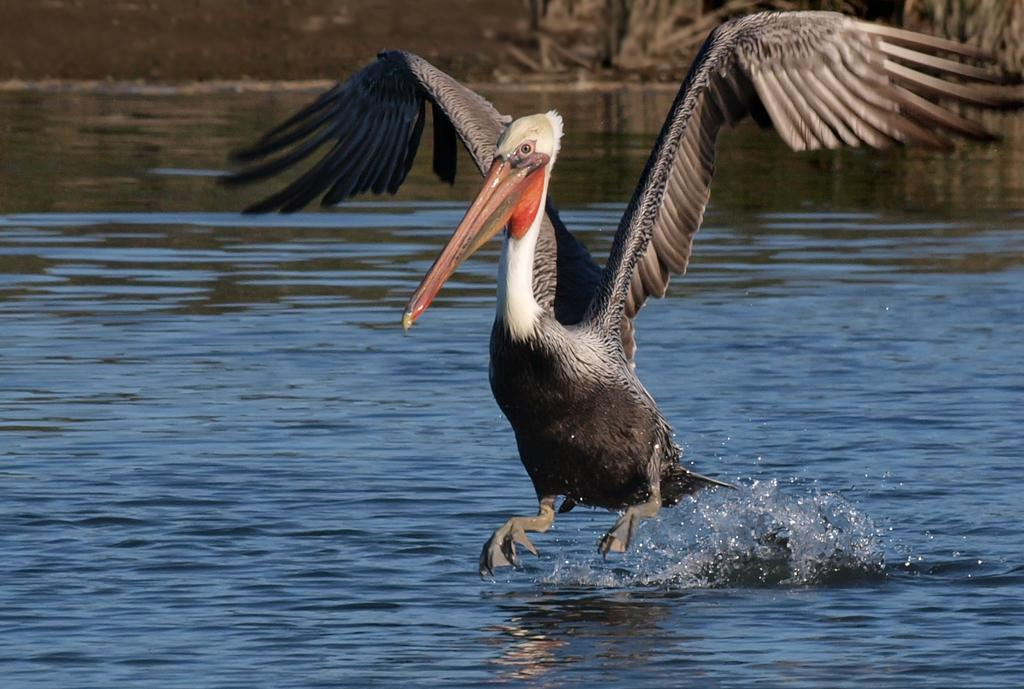What is the main subject of the image? The main subject of the image is a bird flying. What can be seen in the background of the image? There is water visible in the background of the image, along with other objects. What color is the bird's tongue in the image? There is no mention of a tongue in the image, as birds do not have tongues like humans. 